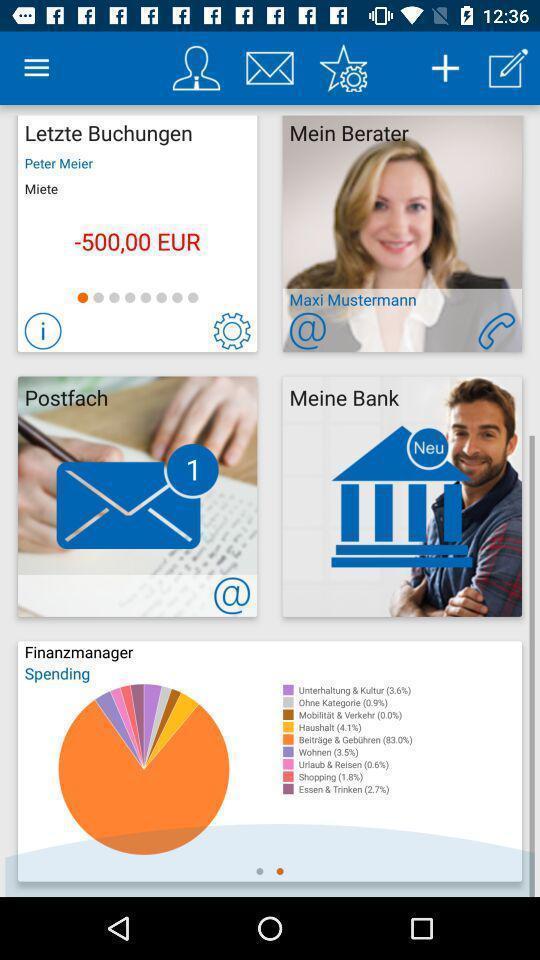Tell me what you see in this picture. Page showing various icons like profile. 